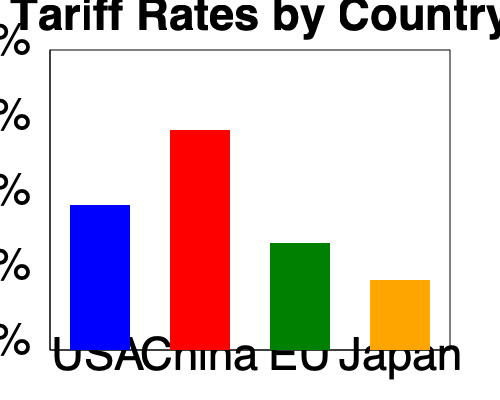Based on the bar graph comparing average tariff rates between different countries and regions, which country or region has implemented the most protectionist trade policy, and how might this impact international trade agreements? To answer this question, we need to analyze the bar graph and understand the implications of tariff rates on trade policies:

1. Interpret the graph:
   - The y-axis represents tariff rates from 5% to 25%.
   - The x-axis shows four countries/regions: USA, China, EU, and Japan.
   - Each bar represents the average tariff rate for that country/region.

2. Compare the tariff rates:
   - USA: approximately 15%
   - China: approximately 20%
   - EU: approximately 12%
   - Japan: approximately 8%

3. Identify the highest tariff rate:
   China has the highest average tariff rate at about 20%.

4. Understand protectionist trade policies:
   Higher tariff rates generally indicate more protectionist trade policies, as they make imported goods more expensive and protect domestic industries.

5. Impact on international trade agreements:
   - China's high tariffs may create barriers to negotiations in trade agreements.
   - Other countries might demand that China lower its tariffs to create a more level playing field.
   - This could lead to prolonged negotiations or potential trade disputes.
   - It may also result in retaliatory measures from other countries, potentially escalating trade tensions.

6. Relevance to the parent involved in politics:
   - This information is crucial for understanding the current state of global trade.
   - It can inform discussions on the benefits and drawbacks of protectionist policies.
   - It may influence political positions on trade agreements and international relations.
Answer: China; highest tariffs may hinder trade agreement negotiations and spark potential disputes. 